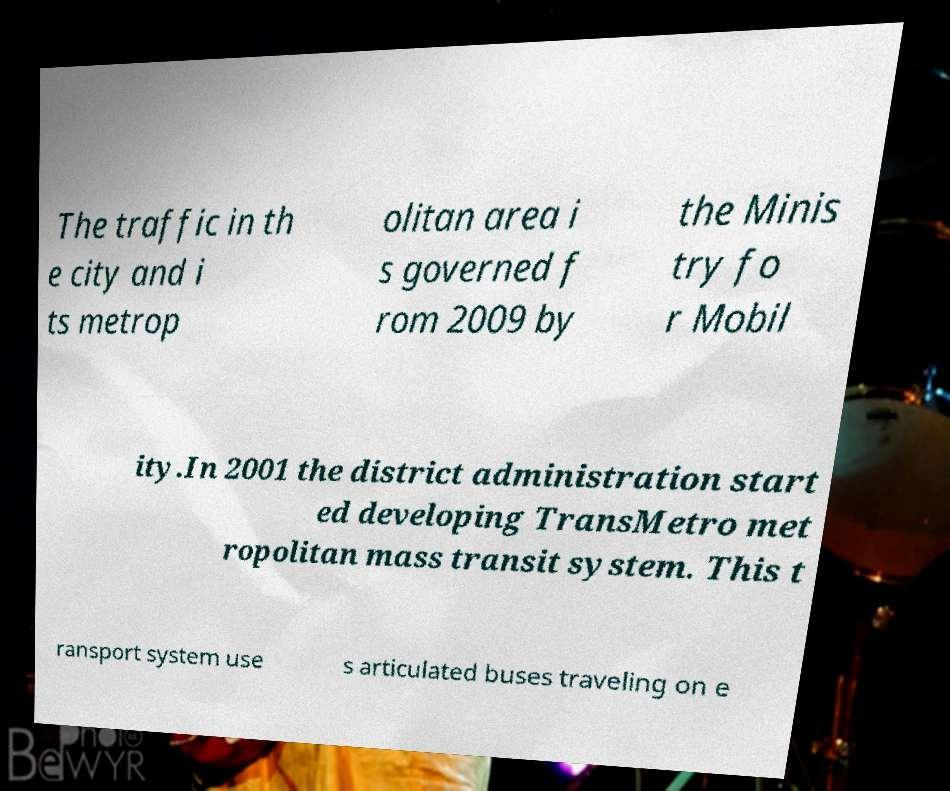Could you assist in decoding the text presented in this image and type it out clearly? The traffic in th e city and i ts metrop olitan area i s governed f rom 2009 by the Minis try fo r Mobil ity.In 2001 the district administration start ed developing TransMetro met ropolitan mass transit system. This t ransport system use s articulated buses traveling on e 